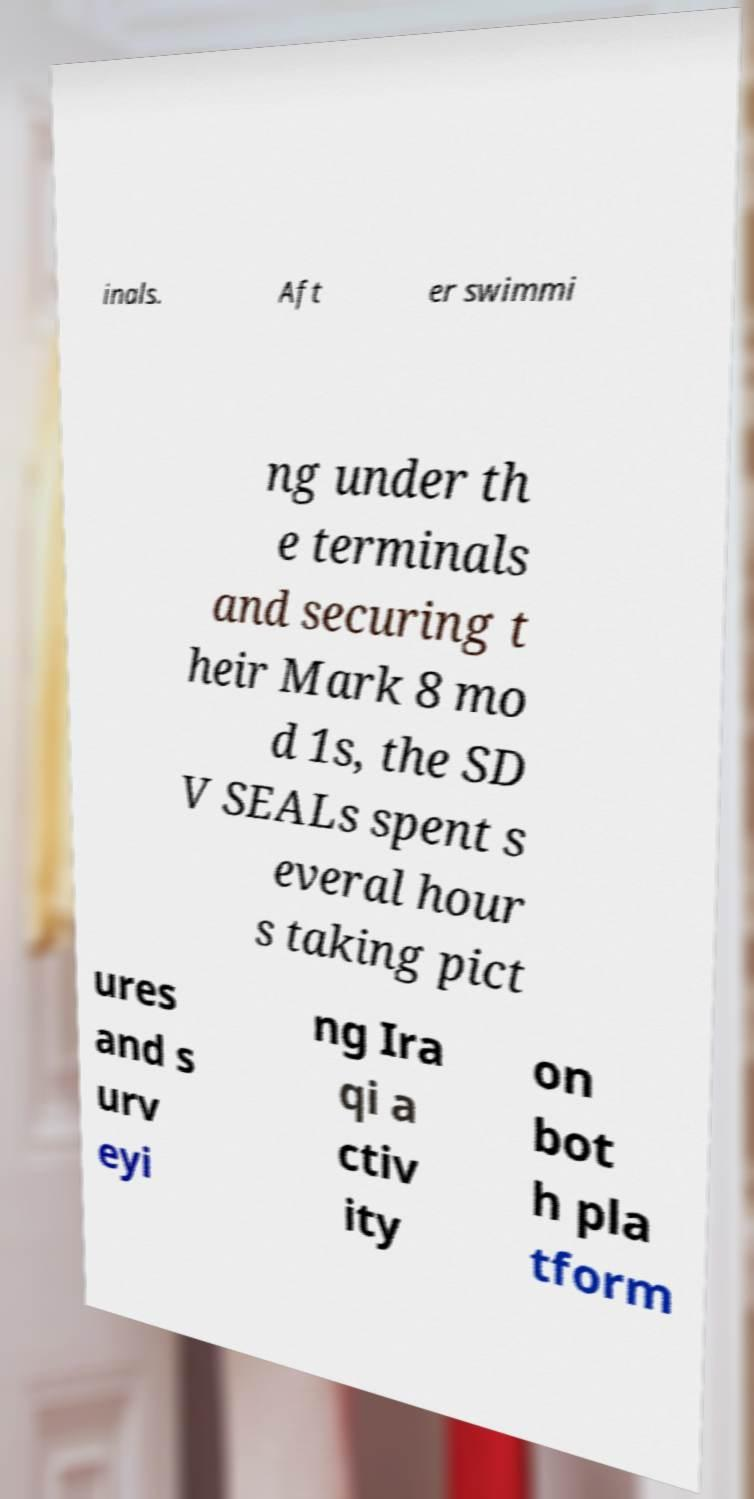What messages or text are displayed in this image? I need them in a readable, typed format. inals. Aft er swimmi ng under th e terminals and securing t heir Mark 8 mo d 1s, the SD V SEALs spent s everal hour s taking pict ures and s urv eyi ng Ira qi a ctiv ity on bot h pla tform 